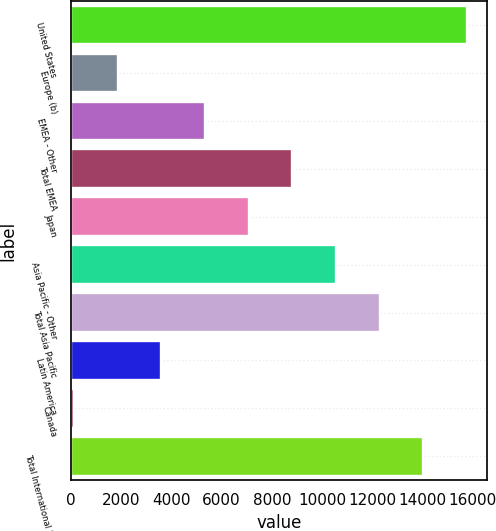Convert chart to OTSL. <chart><loc_0><loc_0><loc_500><loc_500><bar_chart><fcel>United States<fcel>Europe (b)<fcel>EMEA - Other<fcel>Total EMEA<fcel>Japan<fcel>Asia Pacific - Other<fcel>Total Asia Pacific<fcel>Latin America<fcel>Canada<fcel>Total International Retail<nl><fcel>15763.1<fcel>1859.9<fcel>5335.7<fcel>8811.5<fcel>7073.6<fcel>10549.4<fcel>12287.3<fcel>3597.8<fcel>122<fcel>14025.2<nl></chart> 